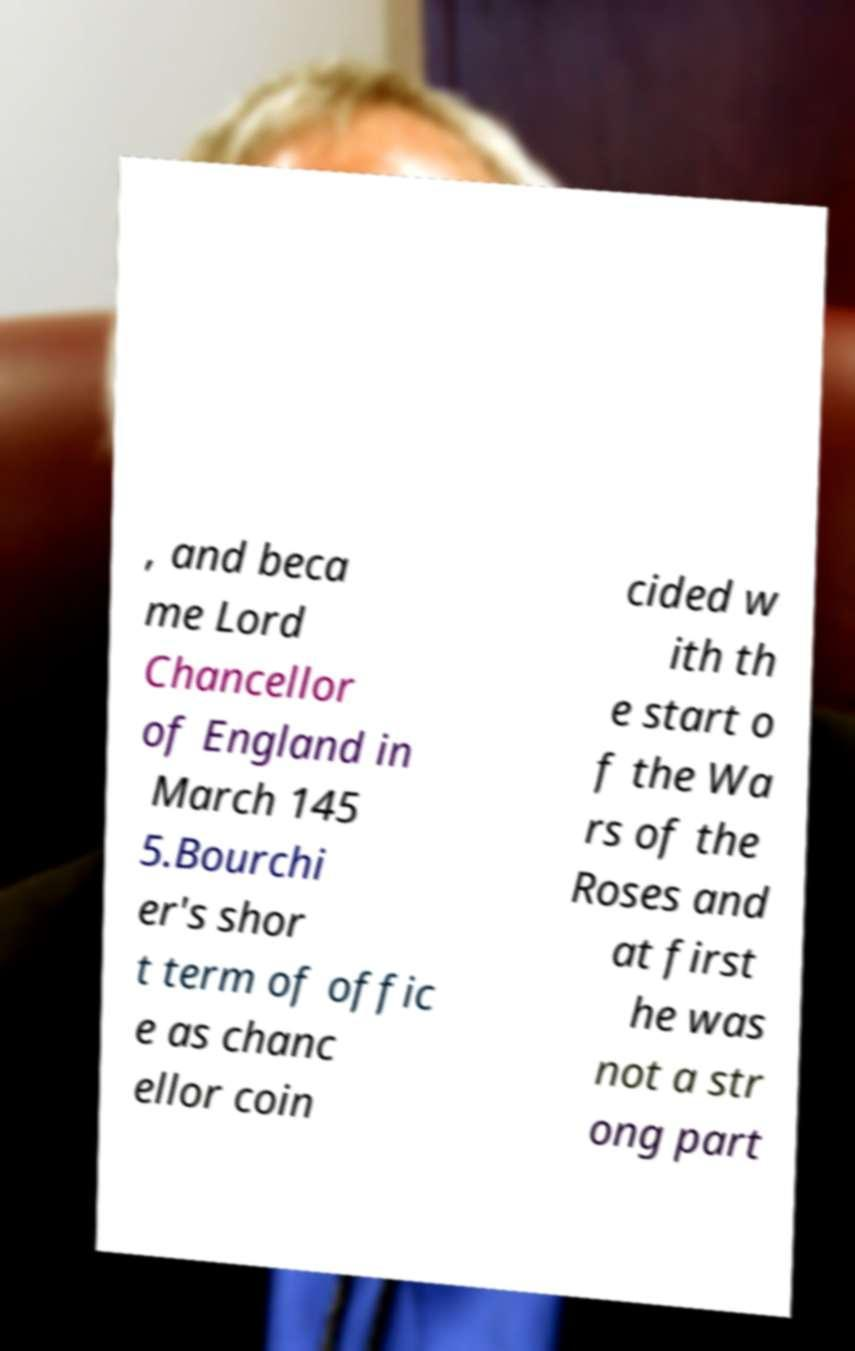What messages or text are displayed in this image? I need them in a readable, typed format. , and beca me Lord Chancellor of England in March 145 5.Bourchi er's shor t term of offic e as chanc ellor coin cided w ith th e start o f the Wa rs of the Roses and at first he was not a str ong part 